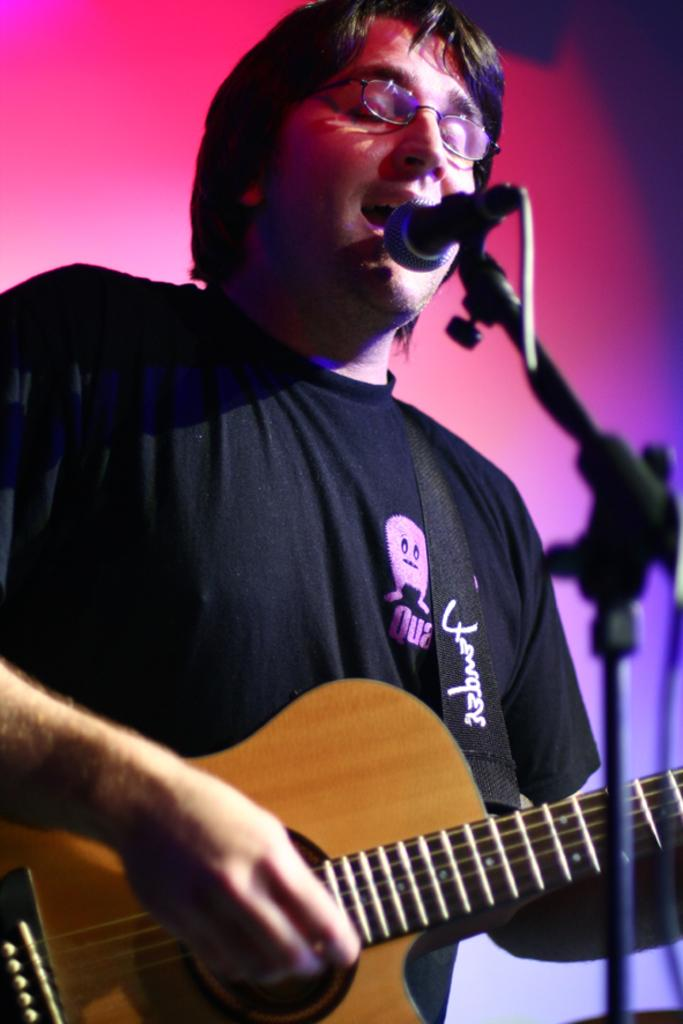What is the man in the image doing? The man is singing and playing a guitar. What instrument is the man is using in the image? The man is playing a guitar. What object is the man holding while singing? The man is holding a microphone. What can be seen in the background of the image? There is a red color light in the background. What is the purpose of the stand in the image? The stand might be used to hold the man's guitar or other equipment. How many cats are visible in the image? There are no cats present in the image. What type of muscle is being exercised by the man in the image? The man is not exercising any muscles in the image; he is singing and playing a guitar. 